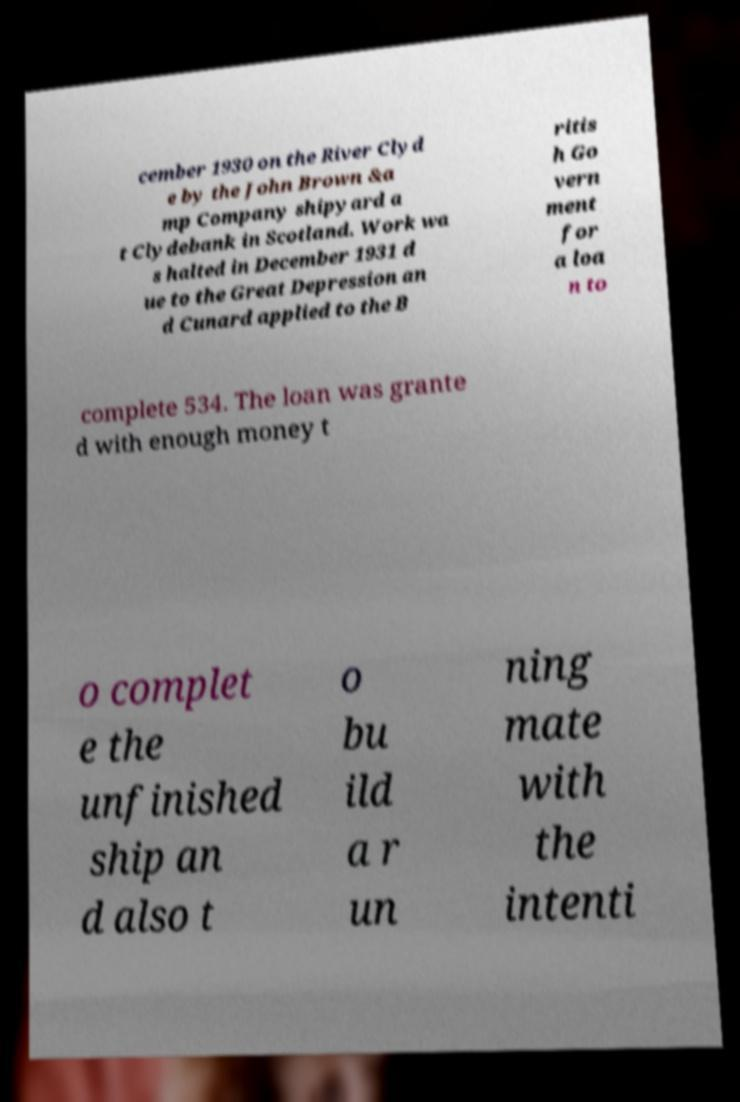I need the written content from this picture converted into text. Can you do that? cember 1930 on the River Clyd e by the John Brown &a mp Company shipyard a t Clydebank in Scotland. Work wa s halted in December 1931 d ue to the Great Depression an d Cunard applied to the B ritis h Go vern ment for a loa n to complete 534. The loan was grante d with enough money t o complet e the unfinished ship an d also t o bu ild a r un ning mate with the intenti 